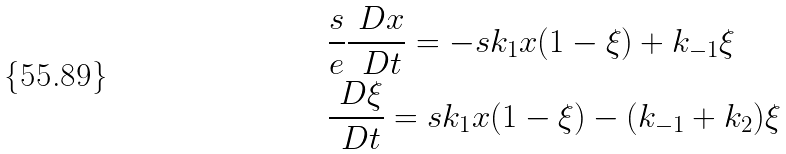Convert formula to latex. <formula><loc_0><loc_0><loc_500><loc_500>& \frac { s } { e } \frac { \ D x } { \ D t } = - s k _ { 1 } x ( 1 - \xi ) + k _ { - 1 } \xi \, \\ & \frac { \ D \xi } { \ D t } = s k _ { 1 } x ( 1 - \xi ) - ( k _ { - 1 } + k _ { 2 } ) \xi \,</formula> 